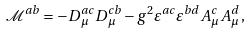Convert formula to latex. <formula><loc_0><loc_0><loc_500><loc_500>\mathcal { M } ^ { a b } = - D ^ { a c } _ { \mu } D ^ { c b } _ { \mu } - g ^ { 2 } \varepsilon ^ { a c } \varepsilon ^ { b d } A ^ { c } _ { \mu } A ^ { d } _ { \mu } \, ,</formula> 